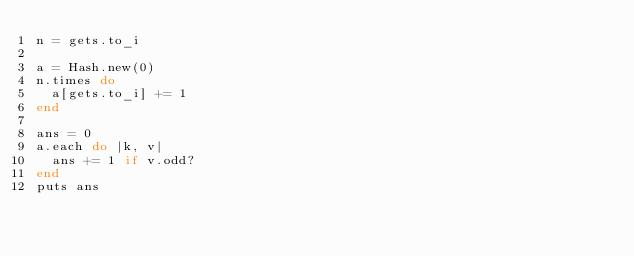<code> <loc_0><loc_0><loc_500><loc_500><_Ruby_>n = gets.to_i

a = Hash.new(0)
n.times do
  a[gets.to_i] += 1
end

ans = 0
a.each do |k, v|
  ans += 1 if v.odd?
end
puts ans
</code> 